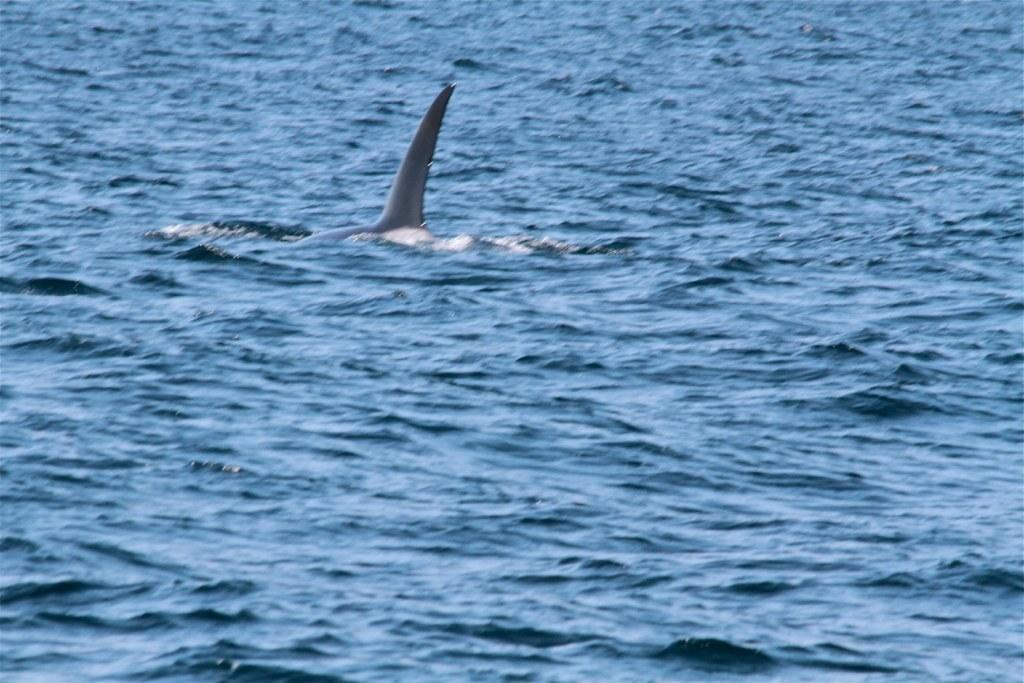What type of animal can be seen in the image? There is an aquatic animal in the image. What color is the water in the image? The water in the image is blue. What is the weight of the doctor in the image? There is no doctor present in the image, so it is not possible to determine their weight. 